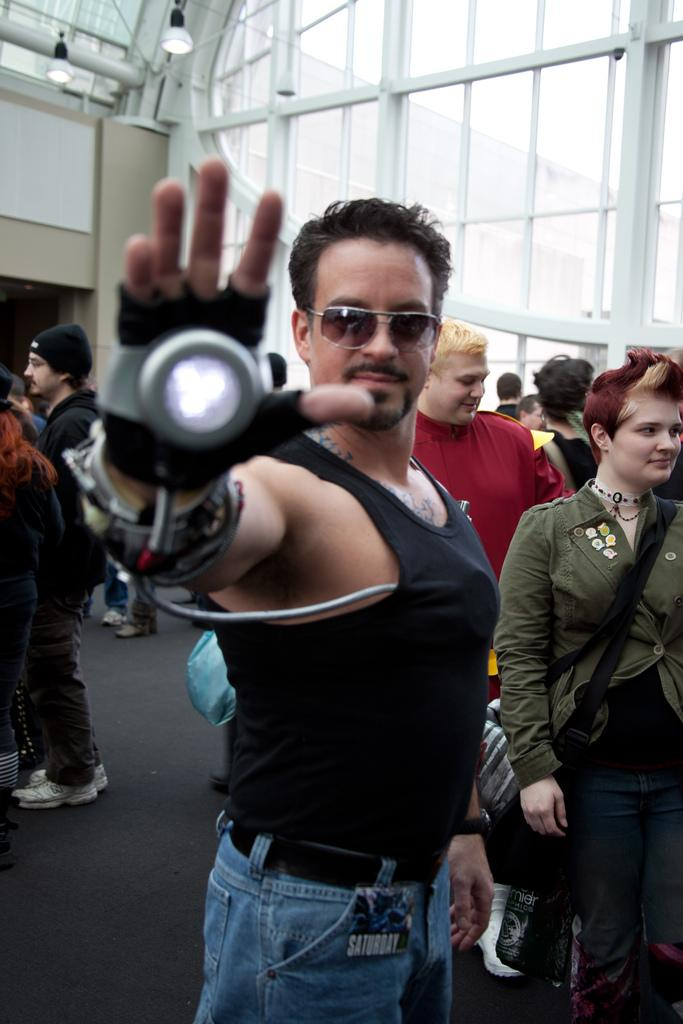How many people are in the image? There are many people in the image. Can you describe any specific clothing or accessories worn by someone in the image? One person is wearing a morpher. What can be seen in the background of the image? There are windows and lights on a wall in the background. What is the surface at the bottom of the image? There is a floor at the bottom of the image. Can you hear the match being struck in the image? There is no match present in the image, so it cannot be struck. Why is the person crying in the image? There is no person crying in the image; the provided facts do not mention any crying or emotional state. 